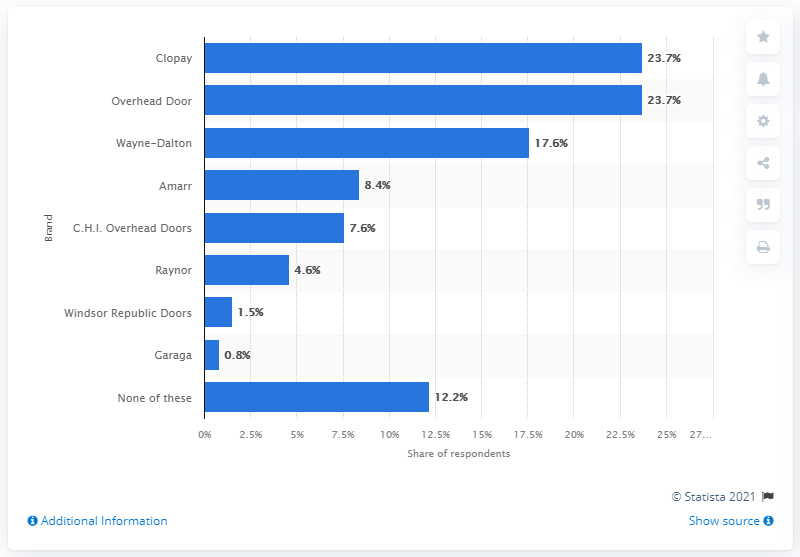Can you describe the trend in brand preference from this visual data? The trend suggests that the top brands like Clopay and Wayne-Dalton dominate the market while smaller brands like Garaga and Windsor Republic Doors hold marginal shares. What could smaller brands do to increase their market share? Smaller brands could focus on niche markets, improve quality, enhance customer service, and increase marketing efforts to build brand awareness and compete with larger brands. 